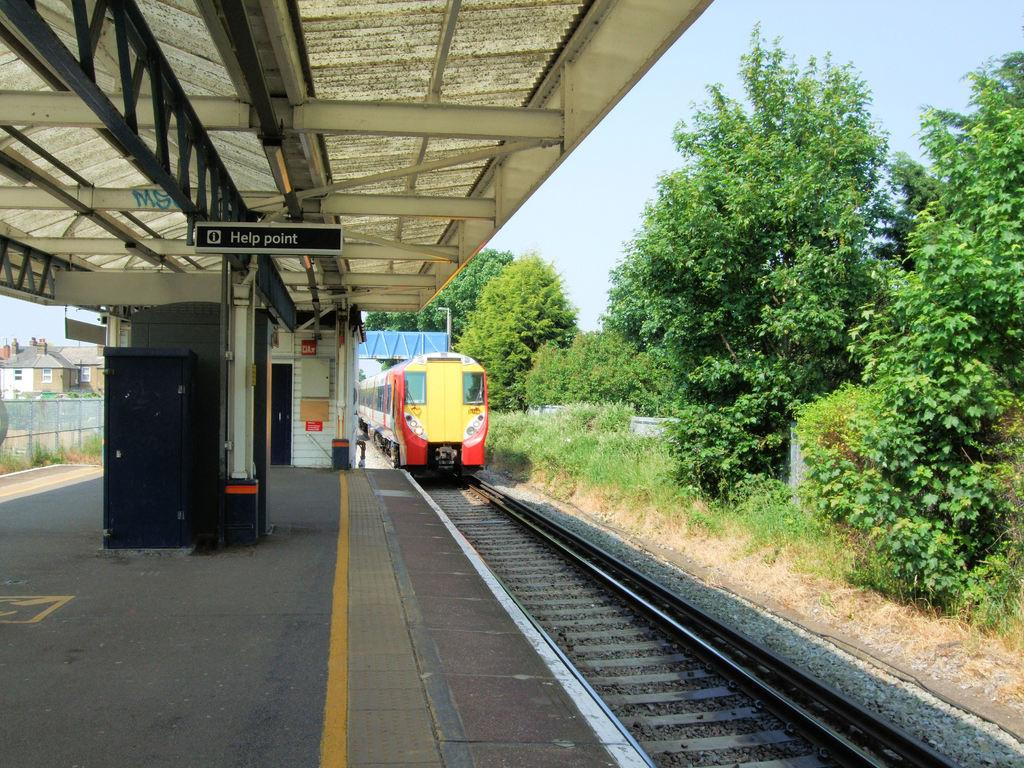<image>
Render a clear and concise summary of the photo. A train is pulling up to a station near a Help Point sign. 